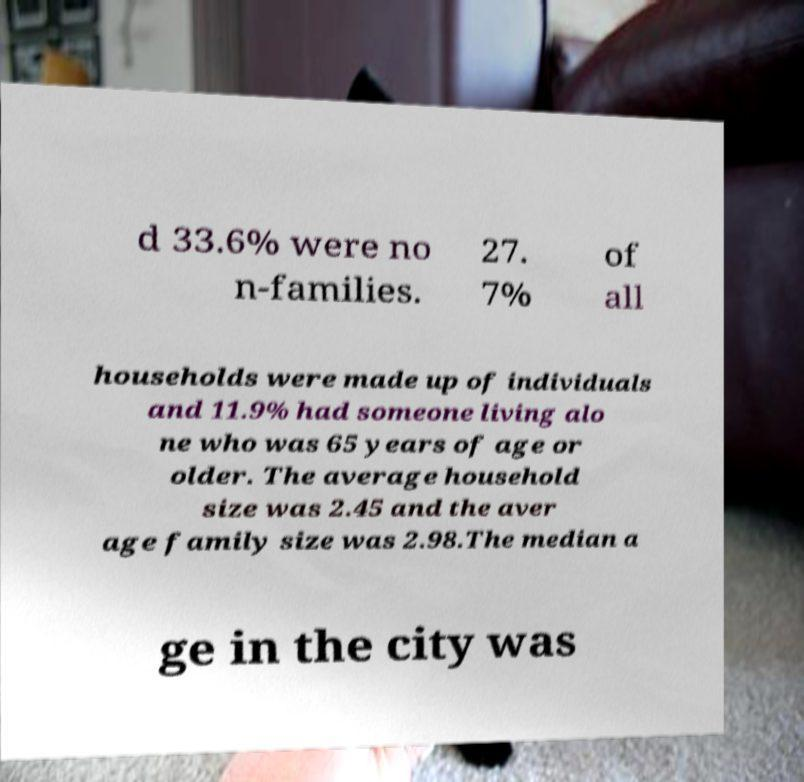Could you assist in decoding the text presented in this image and type it out clearly? d 33.6% were no n-families. 27. 7% of all households were made up of individuals and 11.9% had someone living alo ne who was 65 years of age or older. The average household size was 2.45 and the aver age family size was 2.98.The median a ge in the city was 